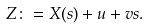<formula> <loc_0><loc_0><loc_500><loc_500>Z \colon = X ( s ) + u + v s .</formula> 